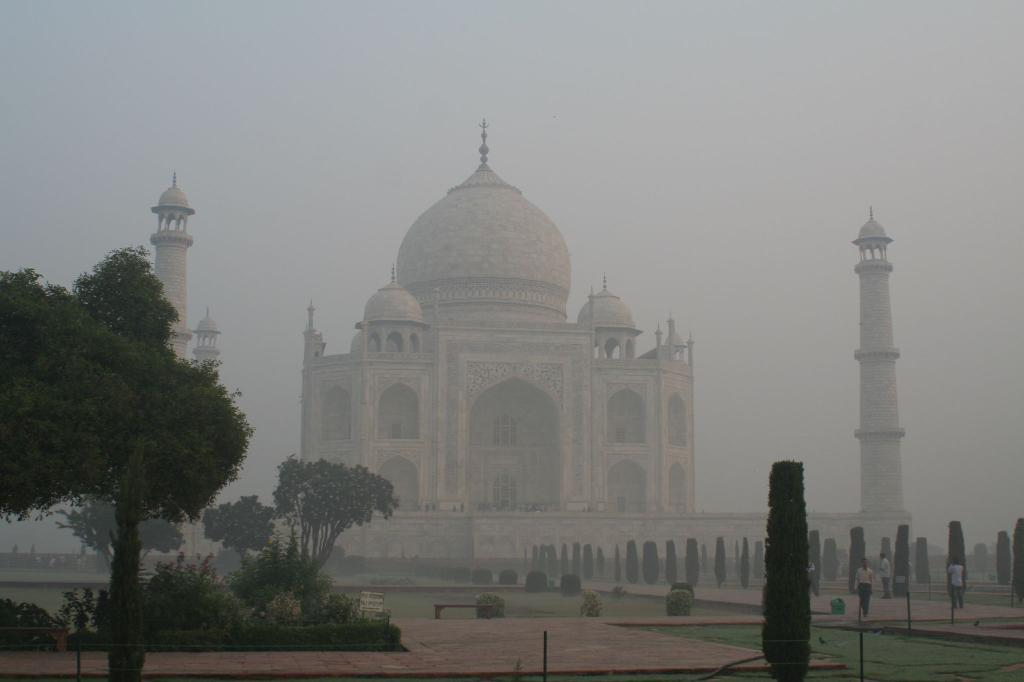What famous landmark is visible in the image? The Taj Mahal is visible in the image. What type of vegetation can be seen in the image? There are plants and trees in the image. Are there any living beings in the image? Yes, there are people in the image. What is the ground covered with in the image? The ground is covered with grass in the image. What can be seen in the background of the image? The sky is visible in the background of the image. What language is being spoken by the boundary in the image? There is no boundary present in the image, and therefore no language can be associated with it. 